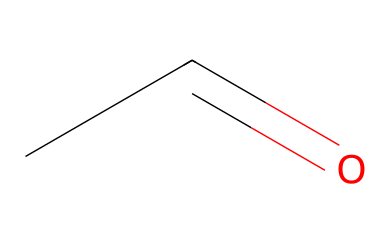What is the name of the chemical represented by this SMILES? The SMILES representation "CC=O" corresponds to a molecule with a two-carbon chain and a carbonyl group, which identifies it as acetaldehyde.
Answer: acetaldehyde How many carbon atoms are in acetaldehyde? By analyzing the SMILES string "CC=O", we can observe that there are two 'C' characters indicating the presence of two carbon atoms.
Answer: 2 What functional group is present in acetaldehyde? The "C=O" part of the SMILES indicates a carbonyl functional group, which is characteristic of aldehydes.
Answer: carbonyl How many hydrogen atoms are in acetaldehyde? Observing the two carbon atoms, we can deduce that acetaldehyde has four hydrogen atoms, considering its saturation and structure as an aldehyde.
Answer: 4 Is acetaldehyde a saturated or unsaturated compound? The presence of a double bond between carbon and oxygen (C=O) and a C=C bond shows that acetaldehyde is unsaturated.
Answer: unsaturated What is the hybridization of the carbon atom in the carbonyl group of acetaldehyde? In the carbonyl group C=O, the carbon atom exhibits sp2 hybridization since it is involved in one double bond and two single bonds.
Answer: sp2 Why is acetaldehyde significant in breathalyzer tests? Acetaldehyde is a product of ethanol metabolism and is measured in breathalyzer tests to estimate blood alcohol content, linking it to intoxication levels.
Answer: blood alcohol content 